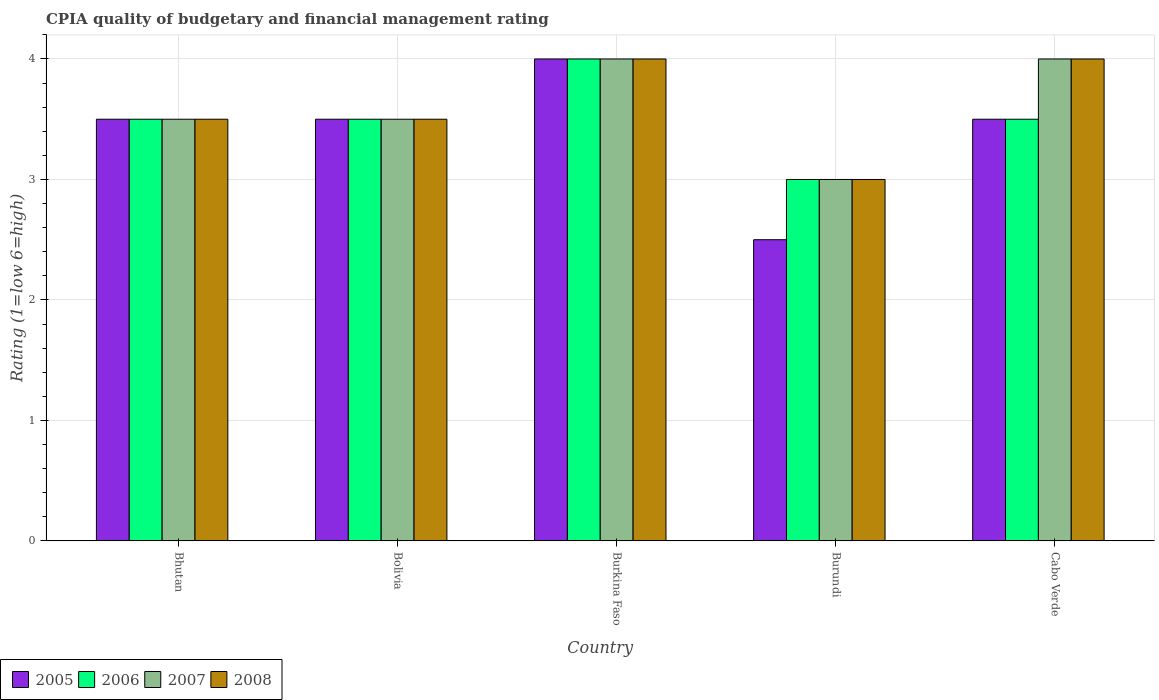How many groups of bars are there?
Your answer should be very brief. 5. Are the number of bars on each tick of the X-axis equal?
Your response must be concise. Yes. How many bars are there on the 2nd tick from the left?
Provide a short and direct response. 4. How many bars are there on the 3rd tick from the right?
Provide a short and direct response. 4. What is the label of the 5th group of bars from the left?
Your answer should be very brief. Cabo Verde. Across all countries, what is the maximum CPIA rating in 2006?
Your answer should be very brief. 4. Across all countries, what is the minimum CPIA rating in 2008?
Provide a short and direct response. 3. In which country was the CPIA rating in 2007 maximum?
Offer a very short reply. Burkina Faso. In which country was the CPIA rating in 2005 minimum?
Your answer should be very brief. Burundi. What is the difference between the CPIA rating in 2007 in Cabo Verde and the CPIA rating in 2006 in Burkina Faso?
Provide a short and direct response. 0. What is the average CPIA rating in 2006 per country?
Ensure brevity in your answer.  3.5. What is the difference between the CPIA rating of/in 2006 and CPIA rating of/in 2007 in Burundi?
Ensure brevity in your answer.  0. In how many countries, is the CPIA rating in 2007 greater than 3.4?
Provide a short and direct response. 4. What is the ratio of the CPIA rating in 2007 in Bhutan to that in Burundi?
Make the answer very short. 1.17. Is the CPIA rating in 2005 in Burundi less than that in Cabo Verde?
Offer a terse response. Yes. Is the difference between the CPIA rating in 2006 in Bhutan and Burundi greater than the difference between the CPIA rating in 2007 in Bhutan and Burundi?
Offer a very short reply. No. What does the 1st bar from the right in Bhutan represents?
Provide a succinct answer. 2008. How many bars are there?
Provide a short and direct response. 20. How are the legend labels stacked?
Ensure brevity in your answer.  Horizontal. What is the title of the graph?
Provide a succinct answer. CPIA quality of budgetary and financial management rating. Does "1963" appear as one of the legend labels in the graph?
Provide a short and direct response. No. What is the label or title of the X-axis?
Offer a terse response. Country. What is the Rating (1=low 6=high) in 2005 in Bhutan?
Make the answer very short. 3.5. What is the Rating (1=low 6=high) in 2006 in Bhutan?
Keep it short and to the point. 3.5. What is the Rating (1=low 6=high) of 2007 in Bhutan?
Provide a succinct answer. 3.5. What is the Rating (1=low 6=high) in 2008 in Bhutan?
Ensure brevity in your answer.  3.5. What is the Rating (1=low 6=high) of 2005 in Bolivia?
Your answer should be compact. 3.5. What is the Rating (1=low 6=high) in 2006 in Bolivia?
Your answer should be compact. 3.5. What is the Rating (1=low 6=high) of 2007 in Bolivia?
Provide a short and direct response. 3.5. What is the Rating (1=low 6=high) of 2005 in Burkina Faso?
Your response must be concise. 4. What is the Rating (1=low 6=high) of 2008 in Burkina Faso?
Give a very brief answer. 4. What is the Rating (1=low 6=high) in 2005 in Burundi?
Keep it short and to the point. 2.5. What is the Rating (1=low 6=high) of 2007 in Burundi?
Your answer should be compact. 3. What is the Rating (1=low 6=high) of 2006 in Cabo Verde?
Your response must be concise. 3.5. What is the Rating (1=low 6=high) of 2008 in Cabo Verde?
Provide a succinct answer. 4. Across all countries, what is the maximum Rating (1=low 6=high) in 2006?
Your response must be concise. 4. Across all countries, what is the maximum Rating (1=low 6=high) in 2007?
Your answer should be compact. 4. Across all countries, what is the maximum Rating (1=low 6=high) in 2008?
Make the answer very short. 4. Across all countries, what is the minimum Rating (1=low 6=high) of 2005?
Keep it short and to the point. 2.5. Across all countries, what is the minimum Rating (1=low 6=high) of 2006?
Your answer should be compact. 3. Across all countries, what is the minimum Rating (1=low 6=high) in 2007?
Give a very brief answer. 3. What is the total Rating (1=low 6=high) of 2005 in the graph?
Your answer should be very brief. 17. What is the total Rating (1=low 6=high) in 2006 in the graph?
Make the answer very short. 17.5. What is the difference between the Rating (1=low 6=high) of 2005 in Bhutan and that in Burkina Faso?
Your response must be concise. -0.5. What is the difference between the Rating (1=low 6=high) of 2007 in Bhutan and that in Burkina Faso?
Your answer should be compact. -0.5. What is the difference between the Rating (1=low 6=high) of 2005 in Bhutan and that in Burundi?
Your answer should be very brief. 1. What is the difference between the Rating (1=low 6=high) of 2007 in Bhutan and that in Burundi?
Your answer should be compact. 0.5. What is the difference between the Rating (1=low 6=high) in 2007 in Bhutan and that in Cabo Verde?
Offer a very short reply. -0.5. What is the difference between the Rating (1=low 6=high) in 2008 in Bhutan and that in Cabo Verde?
Offer a terse response. -0.5. What is the difference between the Rating (1=low 6=high) of 2005 in Bolivia and that in Burkina Faso?
Your response must be concise. -0.5. What is the difference between the Rating (1=low 6=high) in 2007 in Bolivia and that in Burkina Faso?
Ensure brevity in your answer.  -0.5. What is the difference between the Rating (1=low 6=high) in 2007 in Bolivia and that in Burundi?
Provide a short and direct response. 0.5. What is the difference between the Rating (1=low 6=high) of 2008 in Bolivia and that in Burundi?
Ensure brevity in your answer.  0.5. What is the difference between the Rating (1=low 6=high) of 2007 in Burkina Faso and that in Burundi?
Give a very brief answer. 1. What is the difference between the Rating (1=low 6=high) in 2008 in Burkina Faso and that in Burundi?
Your answer should be very brief. 1. What is the difference between the Rating (1=low 6=high) of 2008 in Burkina Faso and that in Cabo Verde?
Offer a very short reply. 0. What is the difference between the Rating (1=low 6=high) in 2006 in Burundi and that in Cabo Verde?
Your answer should be compact. -0.5. What is the difference between the Rating (1=low 6=high) in 2005 in Bhutan and the Rating (1=low 6=high) in 2007 in Burkina Faso?
Provide a short and direct response. -0.5. What is the difference between the Rating (1=low 6=high) in 2006 in Bhutan and the Rating (1=low 6=high) in 2007 in Burkina Faso?
Your response must be concise. -0.5. What is the difference between the Rating (1=low 6=high) in 2006 in Bhutan and the Rating (1=low 6=high) in 2008 in Burkina Faso?
Provide a succinct answer. -0.5. What is the difference between the Rating (1=low 6=high) of 2007 in Bhutan and the Rating (1=low 6=high) of 2008 in Burkina Faso?
Keep it short and to the point. -0.5. What is the difference between the Rating (1=low 6=high) in 2006 in Bhutan and the Rating (1=low 6=high) in 2007 in Burundi?
Your answer should be very brief. 0.5. What is the difference between the Rating (1=low 6=high) in 2006 in Bhutan and the Rating (1=low 6=high) in 2008 in Burundi?
Your answer should be compact. 0.5. What is the difference between the Rating (1=low 6=high) in 2005 in Bhutan and the Rating (1=low 6=high) in 2007 in Cabo Verde?
Your response must be concise. -0.5. What is the difference between the Rating (1=low 6=high) of 2006 in Bhutan and the Rating (1=low 6=high) of 2008 in Cabo Verde?
Make the answer very short. -0.5. What is the difference between the Rating (1=low 6=high) of 2005 in Bolivia and the Rating (1=low 6=high) of 2008 in Burkina Faso?
Your response must be concise. -0.5. What is the difference between the Rating (1=low 6=high) of 2006 in Bolivia and the Rating (1=low 6=high) of 2008 in Burkina Faso?
Give a very brief answer. -0.5. What is the difference between the Rating (1=low 6=high) of 2007 in Bolivia and the Rating (1=low 6=high) of 2008 in Burkina Faso?
Give a very brief answer. -0.5. What is the difference between the Rating (1=low 6=high) of 2005 in Bolivia and the Rating (1=low 6=high) of 2006 in Burundi?
Offer a very short reply. 0.5. What is the difference between the Rating (1=low 6=high) of 2006 in Bolivia and the Rating (1=low 6=high) of 2007 in Burundi?
Offer a terse response. 0.5. What is the difference between the Rating (1=low 6=high) of 2006 in Bolivia and the Rating (1=low 6=high) of 2008 in Burundi?
Your answer should be very brief. 0.5. What is the difference between the Rating (1=low 6=high) in 2007 in Bolivia and the Rating (1=low 6=high) in 2008 in Burundi?
Offer a very short reply. 0.5. What is the difference between the Rating (1=low 6=high) of 2005 in Bolivia and the Rating (1=low 6=high) of 2006 in Cabo Verde?
Make the answer very short. 0. What is the difference between the Rating (1=low 6=high) of 2005 in Bolivia and the Rating (1=low 6=high) of 2007 in Cabo Verde?
Your response must be concise. -0.5. What is the difference between the Rating (1=low 6=high) of 2006 in Bolivia and the Rating (1=low 6=high) of 2008 in Cabo Verde?
Offer a terse response. -0.5. What is the difference between the Rating (1=low 6=high) in 2005 in Burkina Faso and the Rating (1=low 6=high) in 2006 in Burundi?
Offer a very short reply. 1. What is the difference between the Rating (1=low 6=high) in 2005 in Burkina Faso and the Rating (1=low 6=high) in 2007 in Burundi?
Keep it short and to the point. 1. What is the difference between the Rating (1=low 6=high) in 2006 in Burkina Faso and the Rating (1=low 6=high) in 2008 in Burundi?
Your answer should be compact. 1. What is the difference between the Rating (1=low 6=high) of 2005 in Burundi and the Rating (1=low 6=high) of 2006 in Cabo Verde?
Give a very brief answer. -1. What is the difference between the Rating (1=low 6=high) in 2005 in Burundi and the Rating (1=low 6=high) in 2007 in Cabo Verde?
Offer a terse response. -1.5. What is the difference between the Rating (1=low 6=high) in 2006 in Burundi and the Rating (1=low 6=high) in 2008 in Cabo Verde?
Provide a short and direct response. -1. What is the average Rating (1=low 6=high) of 2006 per country?
Offer a terse response. 3.5. What is the average Rating (1=low 6=high) of 2008 per country?
Provide a short and direct response. 3.6. What is the difference between the Rating (1=low 6=high) in 2005 and Rating (1=low 6=high) in 2008 in Bhutan?
Offer a terse response. 0. What is the difference between the Rating (1=low 6=high) of 2006 and Rating (1=low 6=high) of 2008 in Bhutan?
Your answer should be very brief. 0. What is the difference between the Rating (1=low 6=high) of 2007 and Rating (1=low 6=high) of 2008 in Bhutan?
Your answer should be compact. 0. What is the difference between the Rating (1=low 6=high) of 2005 and Rating (1=low 6=high) of 2006 in Bolivia?
Offer a terse response. 0. What is the difference between the Rating (1=low 6=high) of 2005 and Rating (1=low 6=high) of 2008 in Bolivia?
Ensure brevity in your answer.  0. What is the difference between the Rating (1=low 6=high) in 2006 and Rating (1=low 6=high) in 2007 in Bolivia?
Keep it short and to the point. 0. What is the difference between the Rating (1=low 6=high) in 2006 and Rating (1=low 6=high) in 2007 in Burkina Faso?
Make the answer very short. 0. What is the difference between the Rating (1=low 6=high) of 2006 and Rating (1=low 6=high) of 2008 in Burkina Faso?
Provide a succinct answer. 0. What is the difference between the Rating (1=low 6=high) in 2005 and Rating (1=low 6=high) in 2006 in Burundi?
Your response must be concise. -0.5. What is the difference between the Rating (1=low 6=high) in 2005 and Rating (1=low 6=high) in 2008 in Burundi?
Give a very brief answer. -0.5. What is the difference between the Rating (1=low 6=high) in 2006 and Rating (1=low 6=high) in 2007 in Burundi?
Your answer should be very brief. 0. What is the difference between the Rating (1=low 6=high) of 2005 and Rating (1=low 6=high) of 2006 in Cabo Verde?
Make the answer very short. 0. What is the difference between the Rating (1=low 6=high) in 2005 and Rating (1=low 6=high) in 2007 in Cabo Verde?
Make the answer very short. -0.5. What is the difference between the Rating (1=low 6=high) in 2007 and Rating (1=low 6=high) in 2008 in Cabo Verde?
Offer a very short reply. 0. What is the ratio of the Rating (1=low 6=high) of 2007 in Bhutan to that in Bolivia?
Your answer should be very brief. 1. What is the ratio of the Rating (1=low 6=high) in 2006 in Bhutan to that in Burkina Faso?
Offer a very short reply. 0.88. What is the ratio of the Rating (1=low 6=high) in 2007 in Bhutan to that in Burkina Faso?
Your answer should be compact. 0.88. What is the ratio of the Rating (1=low 6=high) in 2008 in Bhutan to that in Burkina Faso?
Provide a succinct answer. 0.88. What is the ratio of the Rating (1=low 6=high) of 2005 in Bhutan to that in Burundi?
Offer a very short reply. 1.4. What is the ratio of the Rating (1=low 6=high) in 2006 in Bhutan to that in Burundi?
Provide a succinct answer. 1.17. What is the ratio of the Rating (1=low 6=high) in 2008 in Bhutan to that in Burundi?
Your answer should be very brief. 1.17. What is the ratio of the Rating (1=low 6=high) of 2005 in Bhutan to that in Cabo Verde?
Make the answer very short. 1. What is the ratio of the Rating (1=low 6=high) of 2006 in Bhutan to that in Cabo Verde?
Your response must be concise. 1. What is the ratio of the Rating (1=low 6=high) in 2006 in Bolivia to that in Burkina Faso?
Keep it short and to the point. 0.88. What is the ratio of the Rating (1=low 6=high) in 2007 in Bolivia to that in Burkina Faso?
Offer a terse response. 0.88. What is the ratio of the Rating (1=low 6=high) in 2008 in Bolivia to that in Burkina Faso?
Provide a short and direct response. 0.88. What is the ratio of the Rating (1=low 6=high) of 2005 in Bolivia to that in Burundi?
Your response must be concise. 1.4. What is the ratio of the Rating (1=low 6=high) in 2005 in Bolivia to that in Cabo Verde?
Your response must be concise. 1. What is the ratio of the Rating (1=low 6=high) in 2006 in Bolivia to that in Cabo Verde?
Offer a terse response. 1. What is the ratio of the Rating (1=low 6=high) in 2008 in Bolivia to that in Cabo Verde?
Offer a very short reply. 0.88. What is the ratio of the Rating (1=low 6=high) of 2007 in Burkina Faso to that in Burundi?
Your answer should be very brief. 1.33. What is the ratio of the Rating (1=low 6=high) of 2005 in Burkina Faso to that in Cabo Verde?
Keep it short and to the point. 1.14. What is the ratio of the Rating (1=low 6=high) in 2007 in Burkina Faso to that in Cabo Verde?
Ensure brevity in your answer.  1. What is the ratio of the Rating (1=low 6=high) of 2006 in Burundi to that in Cabo Verde?
Provide a short and direct response. 0.86. What is the ratio of the Rating (1=low 6=high) of 2007 in Burundi to that in Cabo Verde?
Offer a very short reply. 0.75. What is the ratio of the Rating (1=low 6=high) of 2008 in Burundi to that in Cabo Verde?
Provide a succinct answer. 0.75. What is the difference between the highest and the second highest Rating (1=low 6=high) of 2005?
Your response must be concise. 0.5. What is the difference between the highest and the second highest Rating (1=low 6=high) of 2006?
Offer a very short reply. 0.5. What is the difference between the highest and the second highest Rating (1=low 6=high) in 2007?
Your response must be concise. 0. What is the difference between the highest and the lowest Rating (1=low 6=high) in 2005?
Give a very brief answer. 1.5. What is the difference between the highest and the lowest Rating (1=low 6=high) in 2008?
Keep it short and to the point. 1. 